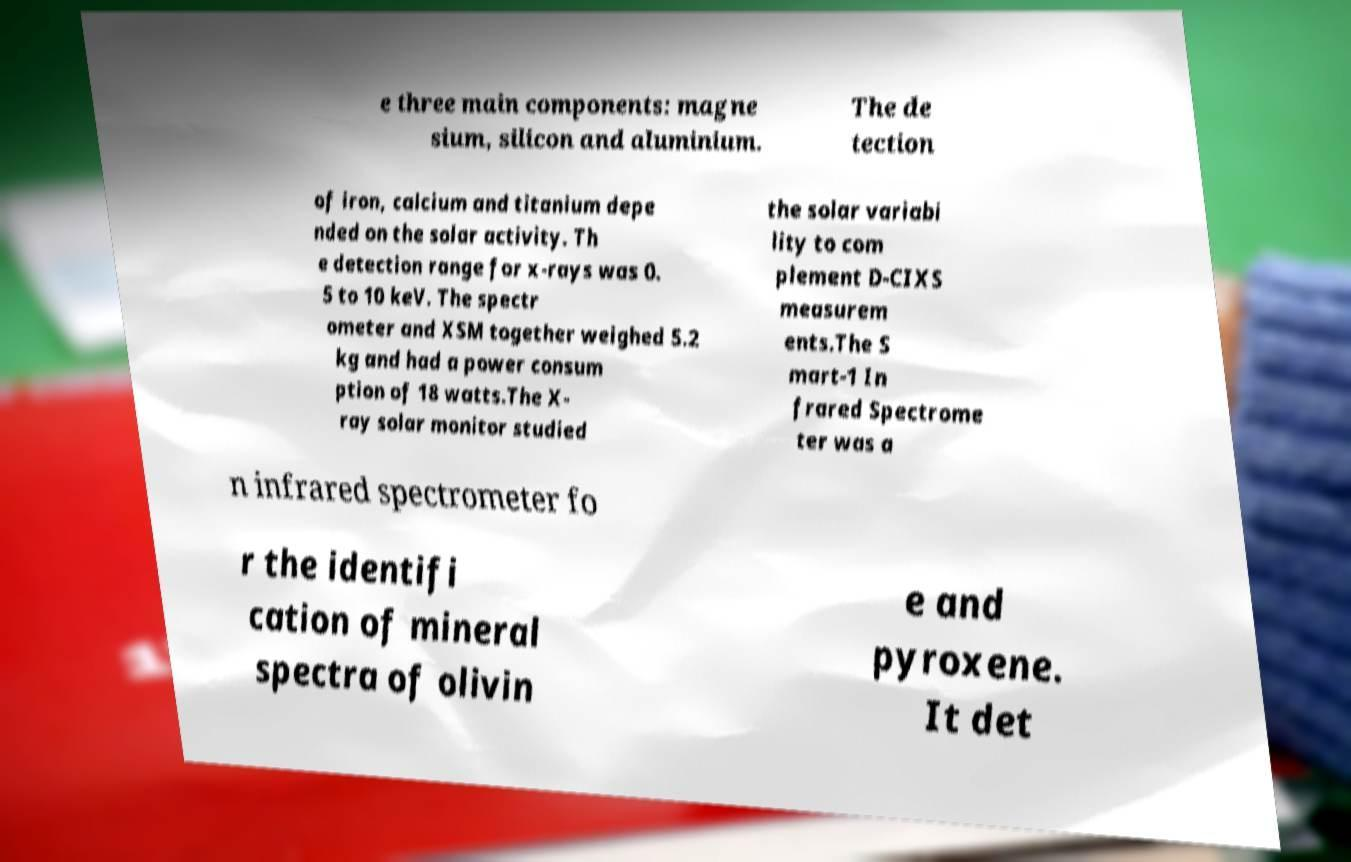Please read and relay the text visible in this image. What does it say? e three main components: magne sium, silicon and aluminium. The de tection of iron, calcium and titanium depe nded on the solar activity. Th e detection range for x-rays was 0. 5 to 10 keV. The spectr ometer and XSM together weighed 5.2 kg and had a power consum ption of 18 watts.The X- ray solar monitor studied the solar variabi lity to com plement D-CIXS measurem ents.The S mart-1 In frared Spectrome ter was a n infrared spectrometer fo r the identifi cation of mineral spectra of olivin e and pyroxene. It det 